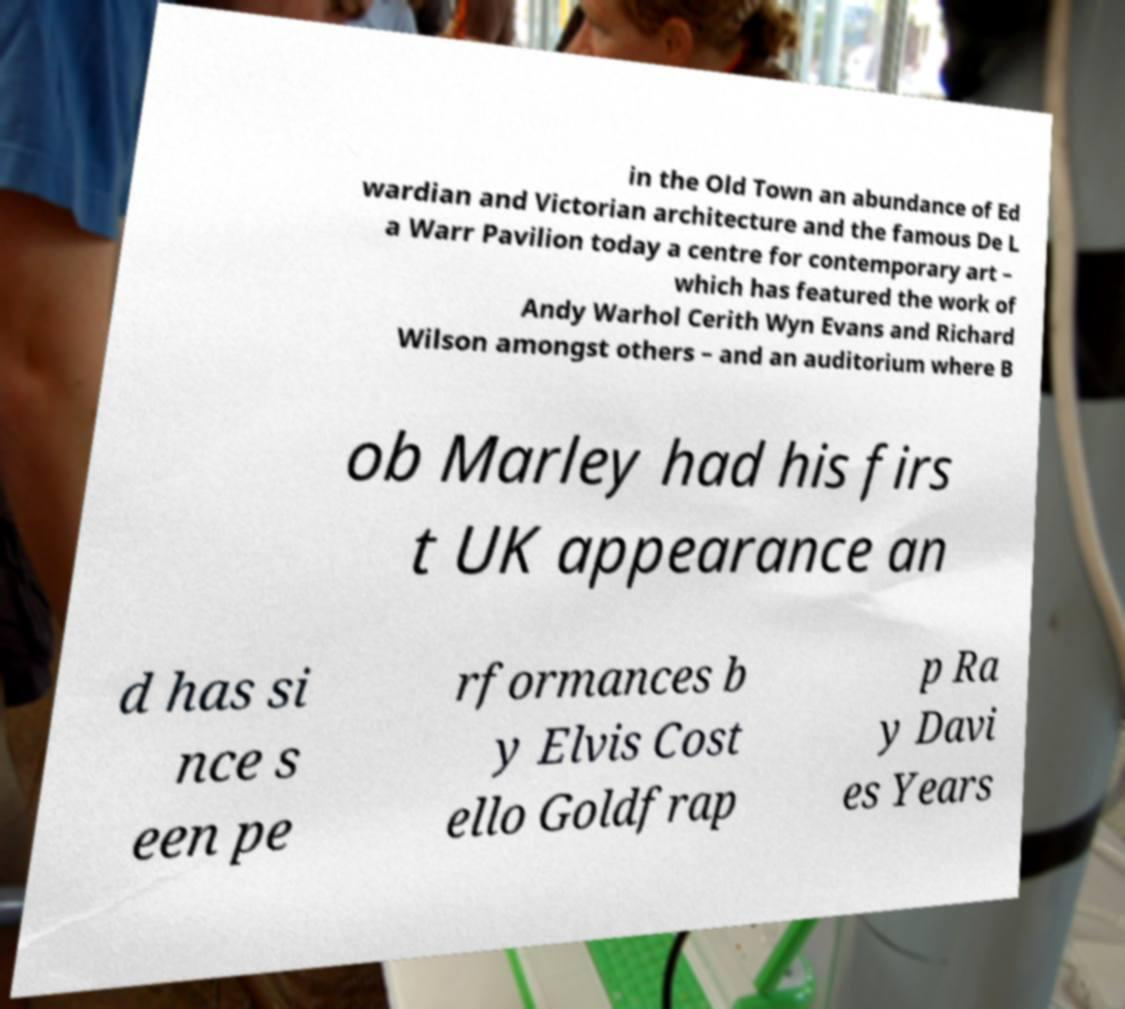What messages or text are displayed in this image? I need them in a readable, typed format. in the Old Town an abundance of Ed wardian and Victorian architecture and the famous De L a Warr Pavilion today a centre for contemporary art – which has featured the work of Andy Warhol Cerith Wyn Evans and Richard Wilson amongst others – and an auditorium where B ob Marley had his firs t UK appearance an d has si nce s een pe rformances b y Elvis Cost ello Goldfrap p Ra y Davi es Years 